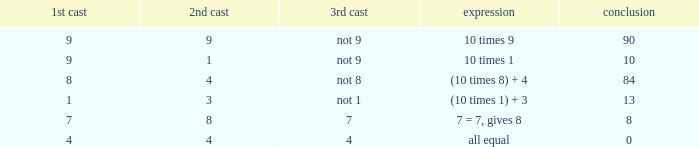If the equation is all equal, what is the 3rd throw? 4.0. 